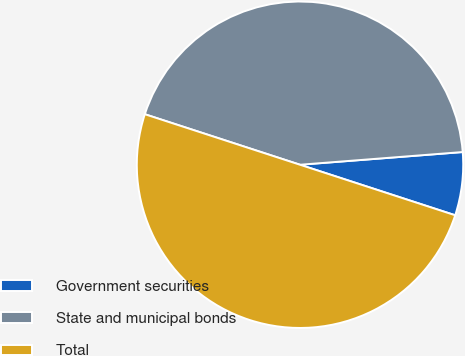Convert chart. <chart><loc_0><loc_0><loc_500><loc_500><pie_chart><fcel>Government securities<fcel>State and municipal bonds<fcel>Total<nl><fcel>6.25%<fcel>43.75%<fcel>50.0%<nl></chart> 